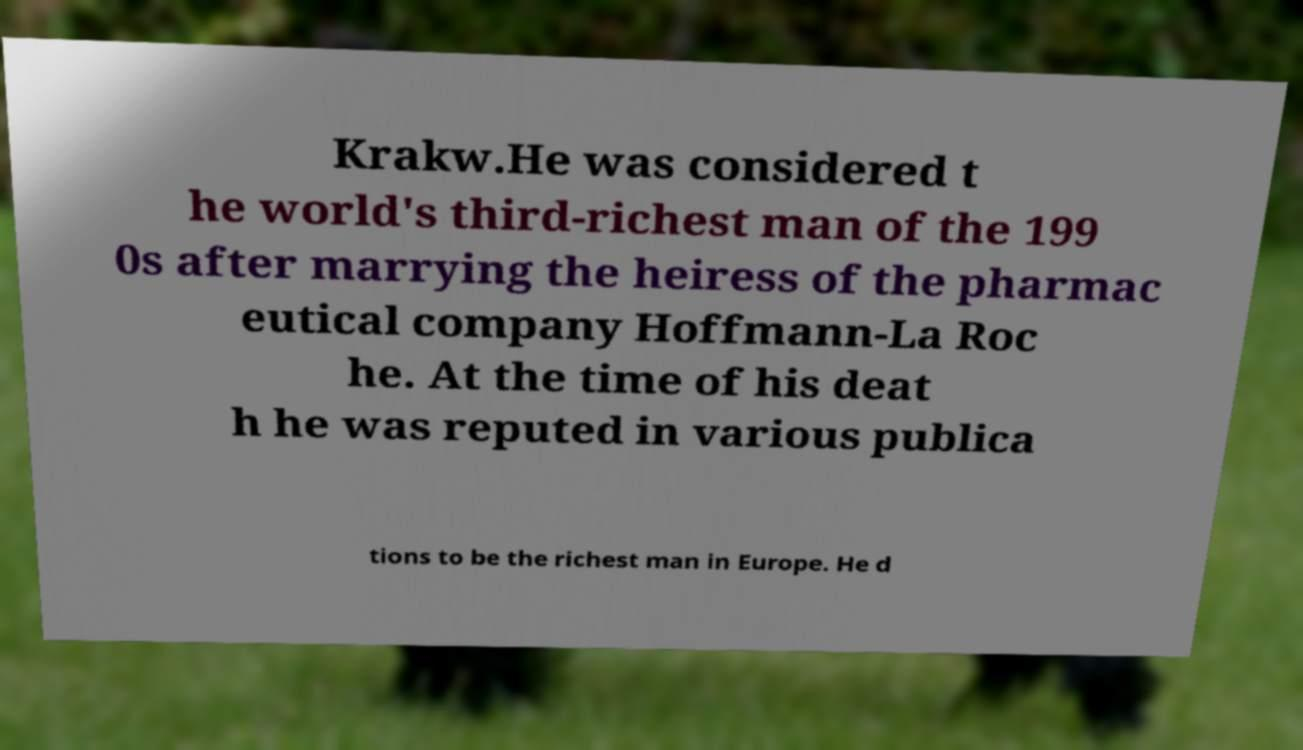Can you accurately transcribe the text from the provided image for me? Krakw.He was considered t he world's third-richest man of the 199 0s after marrying the heiress of the pharmac eutical company Hoffmann-La Roc he. At the time of his deat h he was reputed in various publica tions to be the richest man in Europe. He d 